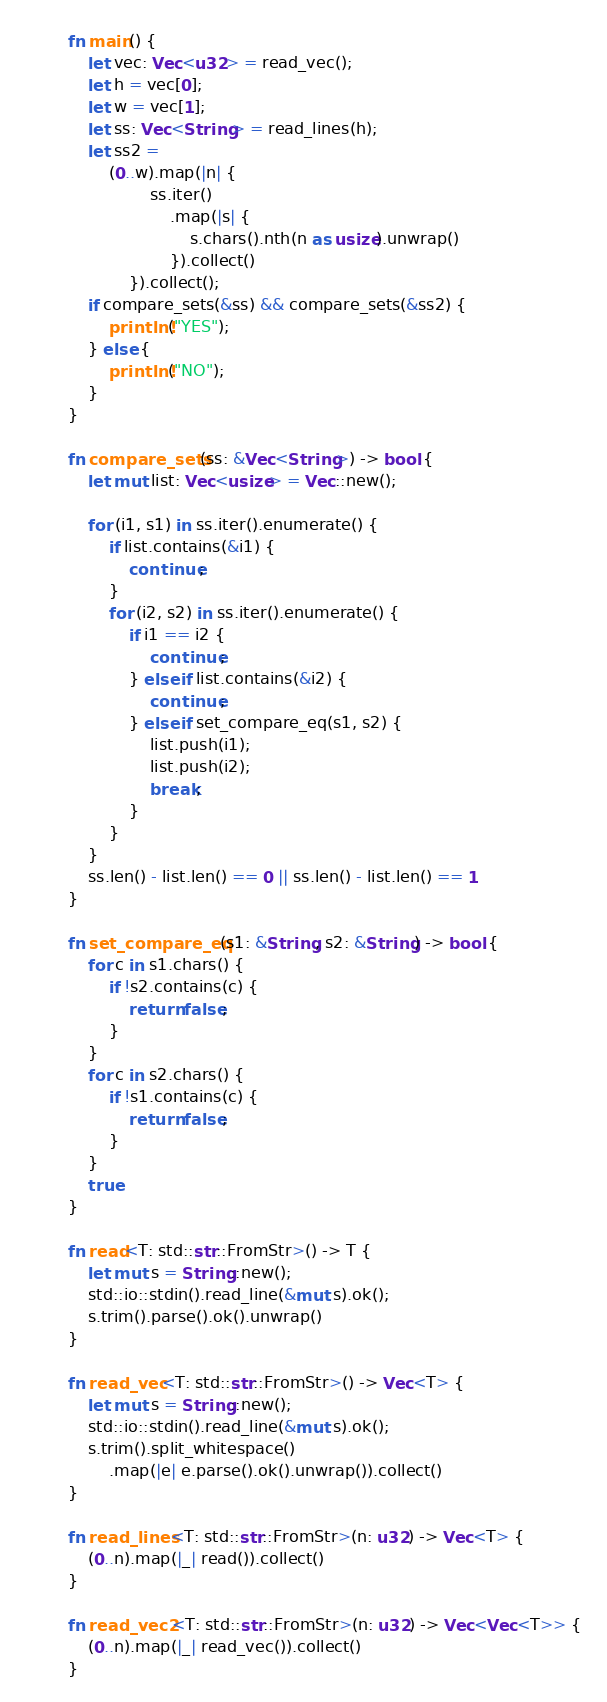<code> <loc_0><loc_0><loc_500><loc_500><_Rust_>fn main() {
    let vec: Vec<u32> = read_vec();
    let h = vec[0];
    let w = vec[1];
    let ss: Vec<String> = read_lines(h);
    let ss2 =
        (0..w).map(|n| {
                ss.iter()
                    .map(|s| {
                        s.chars().nth(n as usize).unwrap()
                    }).collect()
            }).collect();
    if compare_sets(&ss) && compare_sets(&ss2) {
        println!("YES");
    } else {
        println!("NO");
    }
}

fn compare_sets(ss: &Vec<String>) -> bool {
    let mut list: Vec<usize> = Vec::new();

    for (i1, s1) in ss.iter().enumerate() {
        if list.contains(&i1) {
            continue;
        }
        for (i2, s2) in ss.iter().enumerate() {
            if i1 == i2 {
                continue;
            } else if list.contains(&i2) {
                continue;
            } else if set_compare_eq(s1, s2) {
                list.push(i1);
                list.push(i2);
                break;
            }
        }
    }
    ss.len() - list.len() == 0 || ss.len() - list.len() == 1
}

fn set_compare_eq(s1: &String, s2: &String) -> bool {
    for c in s1.chars() {
        if !s2.contains(c) {
            return false;
        }
    }
    for c in s2.chars() {
        if !s1.contains(c) {
            return false;
        }
    }
    true
}

fn read<T: std::str::FromStr>() -> T {
    let mut s = String::new();
    std::io::stdin().read_line(&mut s).ok();
    s.trim().parse().ok().unwrap()
}

fn read_vec<T: std::str::FromStr>() -> Vec<T> {
    let mut s = String::new();
    std::io::stdin().read_line(&mut s).ok();
    s.trim().split_whitespace()
        .map(|e| e.parse().ok().unwrap()).collect()
}

fn read_lines<T: std::str::FromStr>(n: u32) -> Vec<T> {
    (0..n).map(|_| read()).collect()
}

fn read_vec2<T: std::str::FromStr>(n: u32) -> Vec<Vec<T>> {
    (0..n).map(|_| read_vec()).collect()
}</code> 